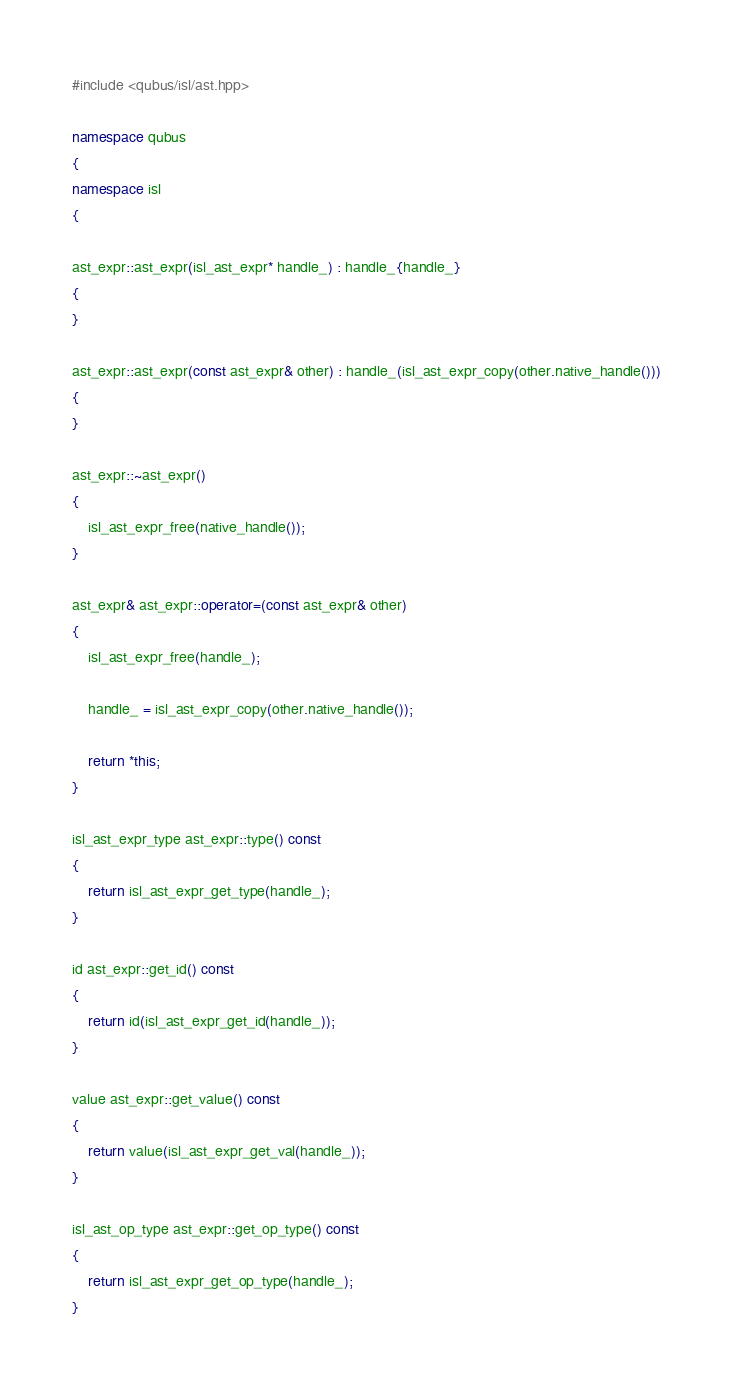<code> <loc_0><loc_0><loc_500><loc_500><_C++_>#include <qubus/isl/ast.hpp>

namespace qubus
{
namespace isl
{

ast_expr::ast_expr(isl_ast_expr* handle_) : handle_{handle_}
{
}

ast_expr::ast_expr(const ast_expr& other) : handle_(isl_ast_expr_copy(other.native_handle()))
{
}

ast_expr::~ast_expr()
{
    isl_ast_expr_free(native_handle());
}

ast_expr& ast_expr::operator=(const ast_expr& other)
{
    isl_ast_expr_free(handle_);

    handle_ = isl_ast_expr_copy(other.native_handle());

    return *this;
}

isl_ast_expr_type ast_expr::type() const
{
    return isl_ast_expr_get_type(handle_);
}

id ast_expr::get_id() const
{
    return id(isl_ast_expr_get_id(handle_));
}

value ast_expr::get_value() const
{
    return value(isl_ast_expr_get_val(handle_));
}

isl_ast_op_type ast_expr::get_op_type() const
{
    return isl_ast_expr_get_op_type(handle_);
}
</code> 